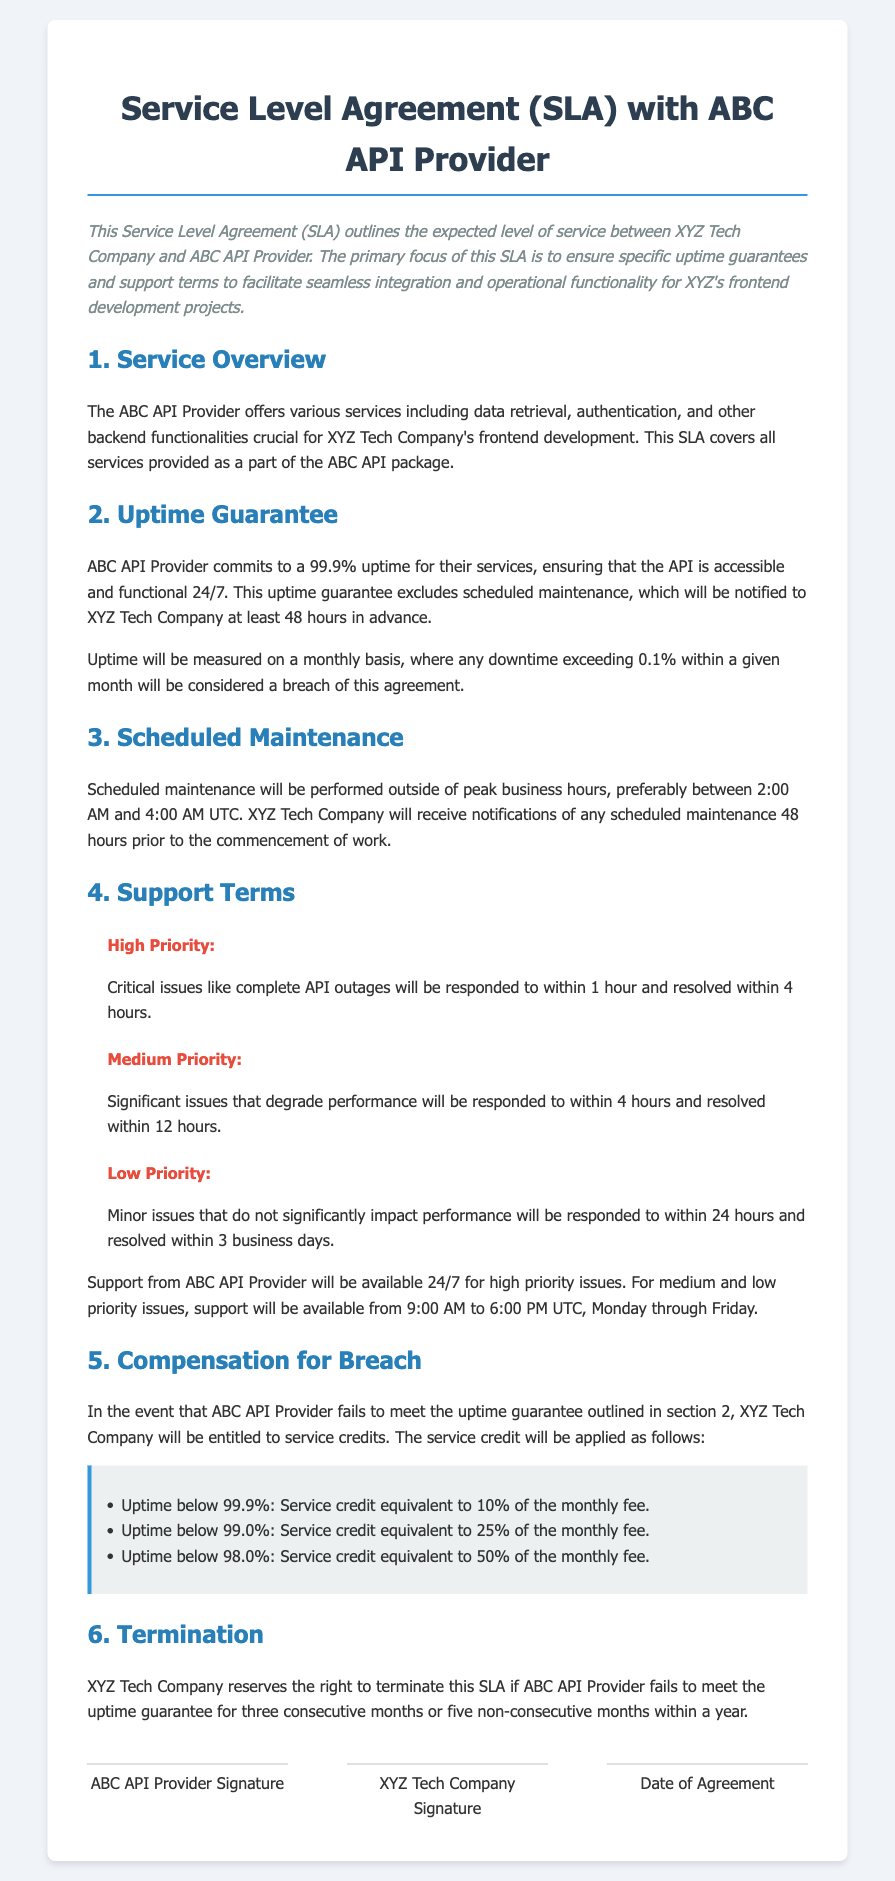what is the uptime guarantee percentage? The uptime guarantee percentage, as specified in the SLA, is 99.9%.
Answer: 99.9% how long will critical issues be responded to in? The SLA states that critical issues will be responded to within 1 hour.
Answer: 1 hour what is the compensation for uptime below 98.0%? For uptime below 98.0%, the service credit is equivalent to 50% of the monthly fee.
Answer: 50% when is support available for medium and low priority issues? Support for medium and low priority issues is available from 9:00 AM to 6:00 PM UTC, Monday through Friday.
Answer: 9:00 AM to 6:00 PM UTC, Monday through Friday what is the maximum allowed downtime in a month? The maximum allowed downtime in a month, based on the 99.9% uptime guarantee, is 0.1%.
Answer: 0.1% how many consecutive months can the SLA be breached before termination? The SLA can be breached for three consecutive months before XYZ Tech Company can terminate it.
Answer: three what hours are scheduled maintenance performed? Scheduled maintenance will be performed preferably between 2:00 AM and 4:00 AM UTC.
Answer: 2:00 AM to 4:00 AM UTC 